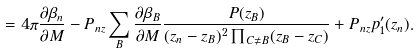Convert formula to latex. <formula><loc_0><loc_0><loc_500><loc_500>= 4 \pi \frac { \partial \beta _ { n } } { \partial M } - P _ { n z } \sum _ { B } \frac { \partial \beta _ { B } } { \partial M } \frac { P ( z _ { B } ) } { ( z _ { n } - z _ { B } ) ^ { 2 } \prod _ { C \neq B } ( z _ { B } - z _ { C } ) } + P _ { n z } p _ { 1 } ^ { \prime } ( z _ { n } ) .</formula> 